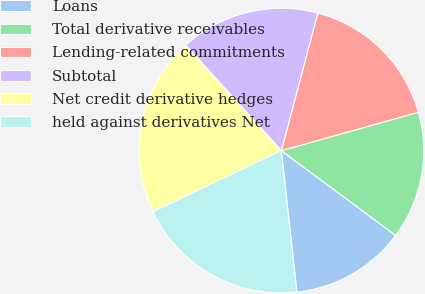Convert chart to OTSL. <chart><loc_0><loc_0><loc_500><loc_500><pie_chart><fcel>Loans<fcel>Total derivative receivables<fcel>Lending-related commitments<fcel>Subtotal<fcel>Net credit derivative hedges<fcel>held against derivatives Net<nl><fcel>13.11%<fcel>14.5%<fcel>16.53%<fcel>15.85%<fcel>20.34%<fcel>19.67%<nl></chart> 